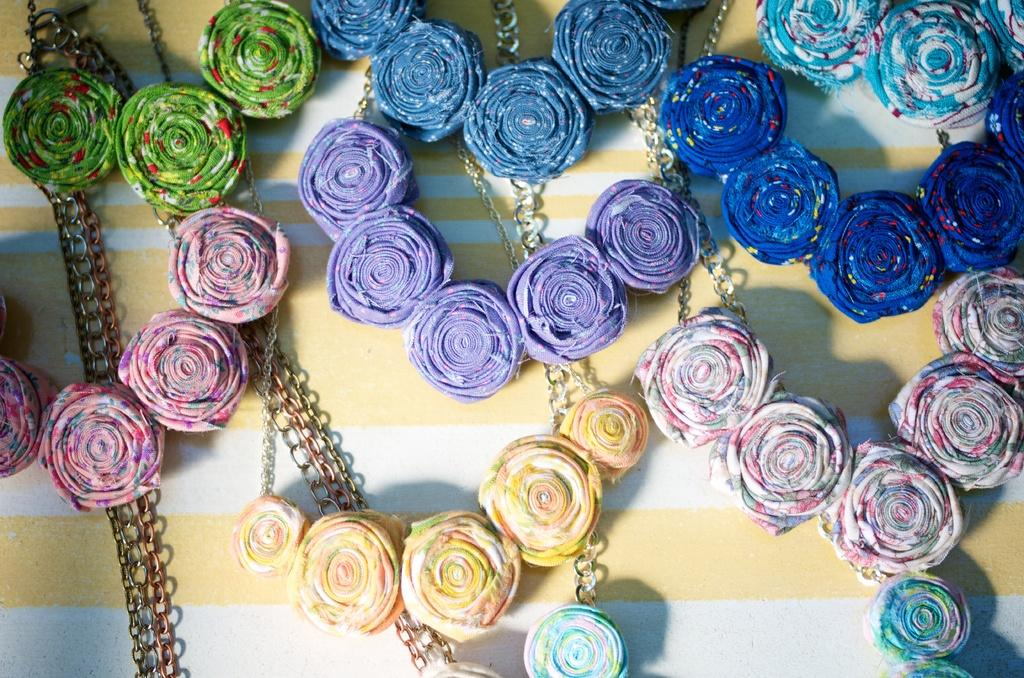What type of flowers are depicted in the image? There are colorful handmade roses in the image. What material are the roses made of? The roses are made of cloth. Where are the roses located in the image? The roses are on a table. What connects the roses in the image? There are chains between the roses in the image. What decision does the team make regarding the rifle in the image? There is no rifle present in the image, so the question about a team's decision is not applicable. 